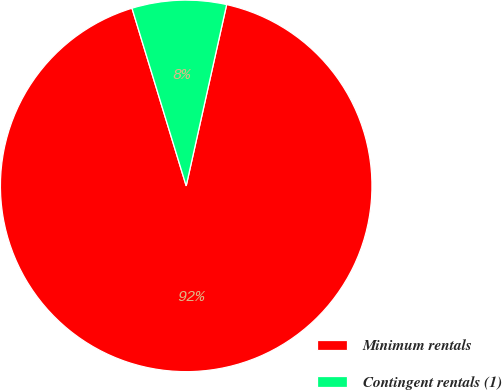Convert chart to OTSL. <chart><loc_0><loc_0><loc_500><loc_500><pie_chart><fcel>Minimum rentals<fcel>Contingent rentals (1)<nl><fcel>91.79%<fcel>8.21%<nl></chart> 